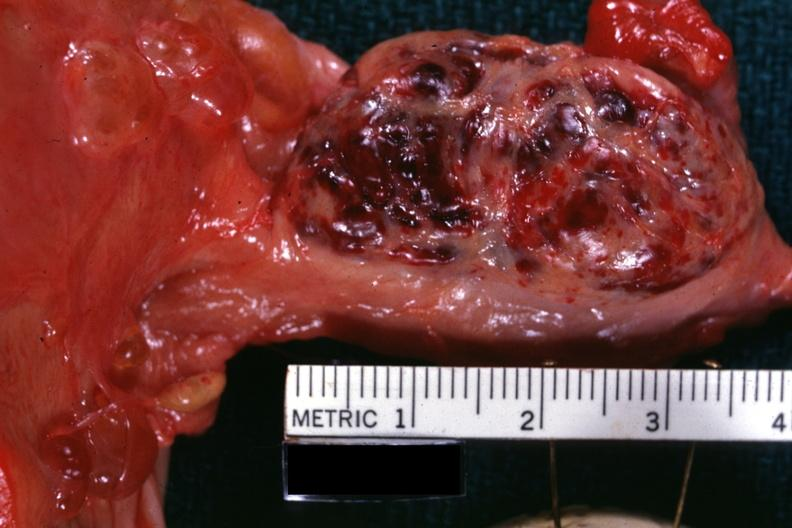what is a corpus luteum from photo?
Answer the question using a single word or phrase. This 